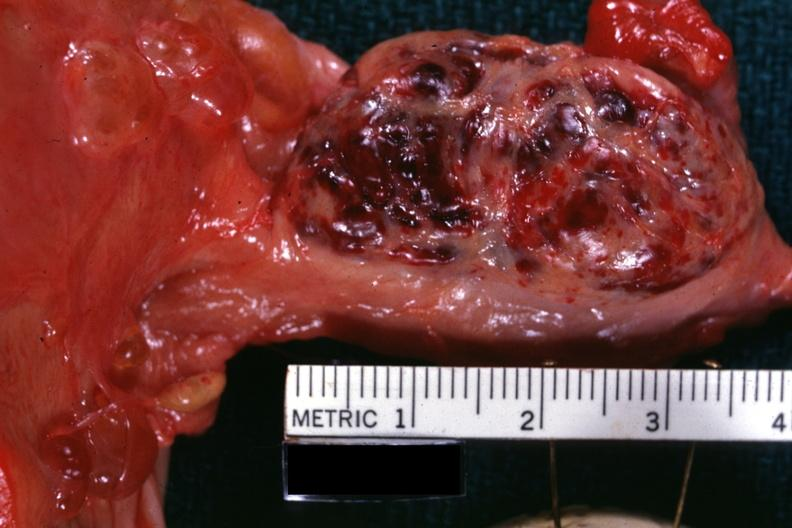what is a corpus luteum from photo?
Answer the question using a single word or phrase. This 